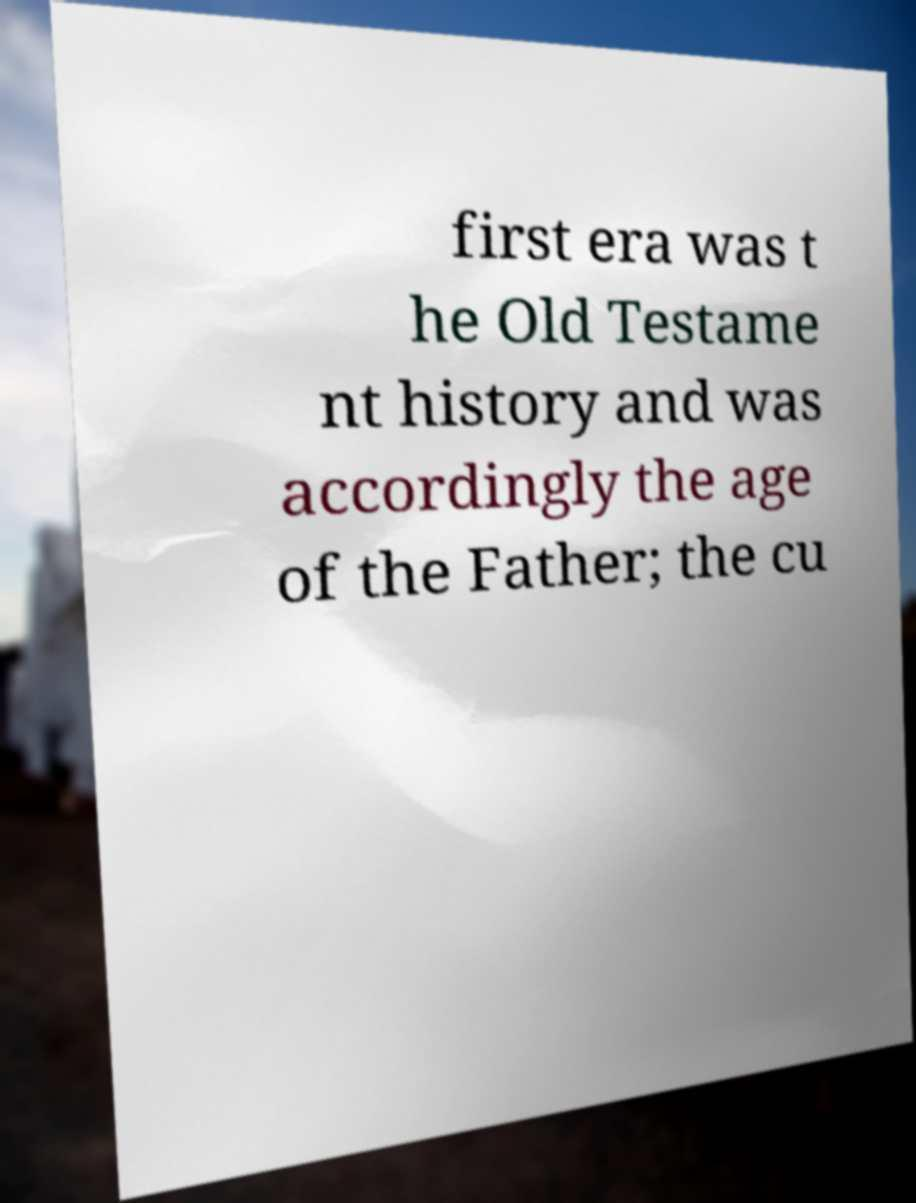Can you accurately transcribe the text from the provided image for me? first era was t he Old Testame nt history and was accordingly the age of the Father; the cu 